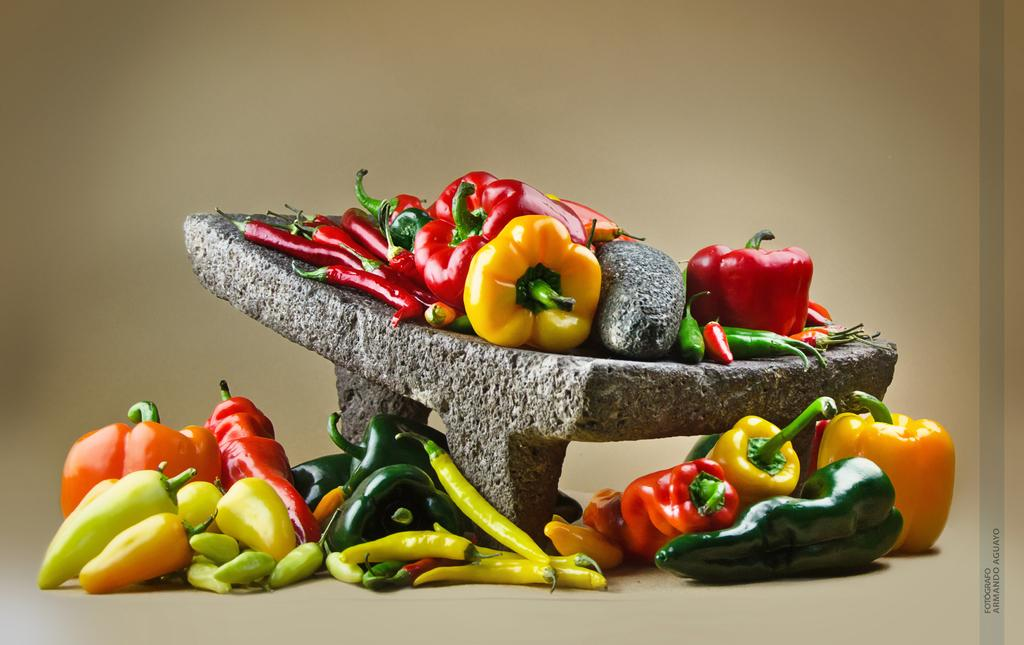What types of objects are present in the image? There are different types of chills in the image. Can you describe the placement of some of the chills? Some chills are placed on a stone, while others are placed on a surface. How many ducks are swimming in the water near the chills? There are no ducks or water present in the image; it only features different types of chills. 